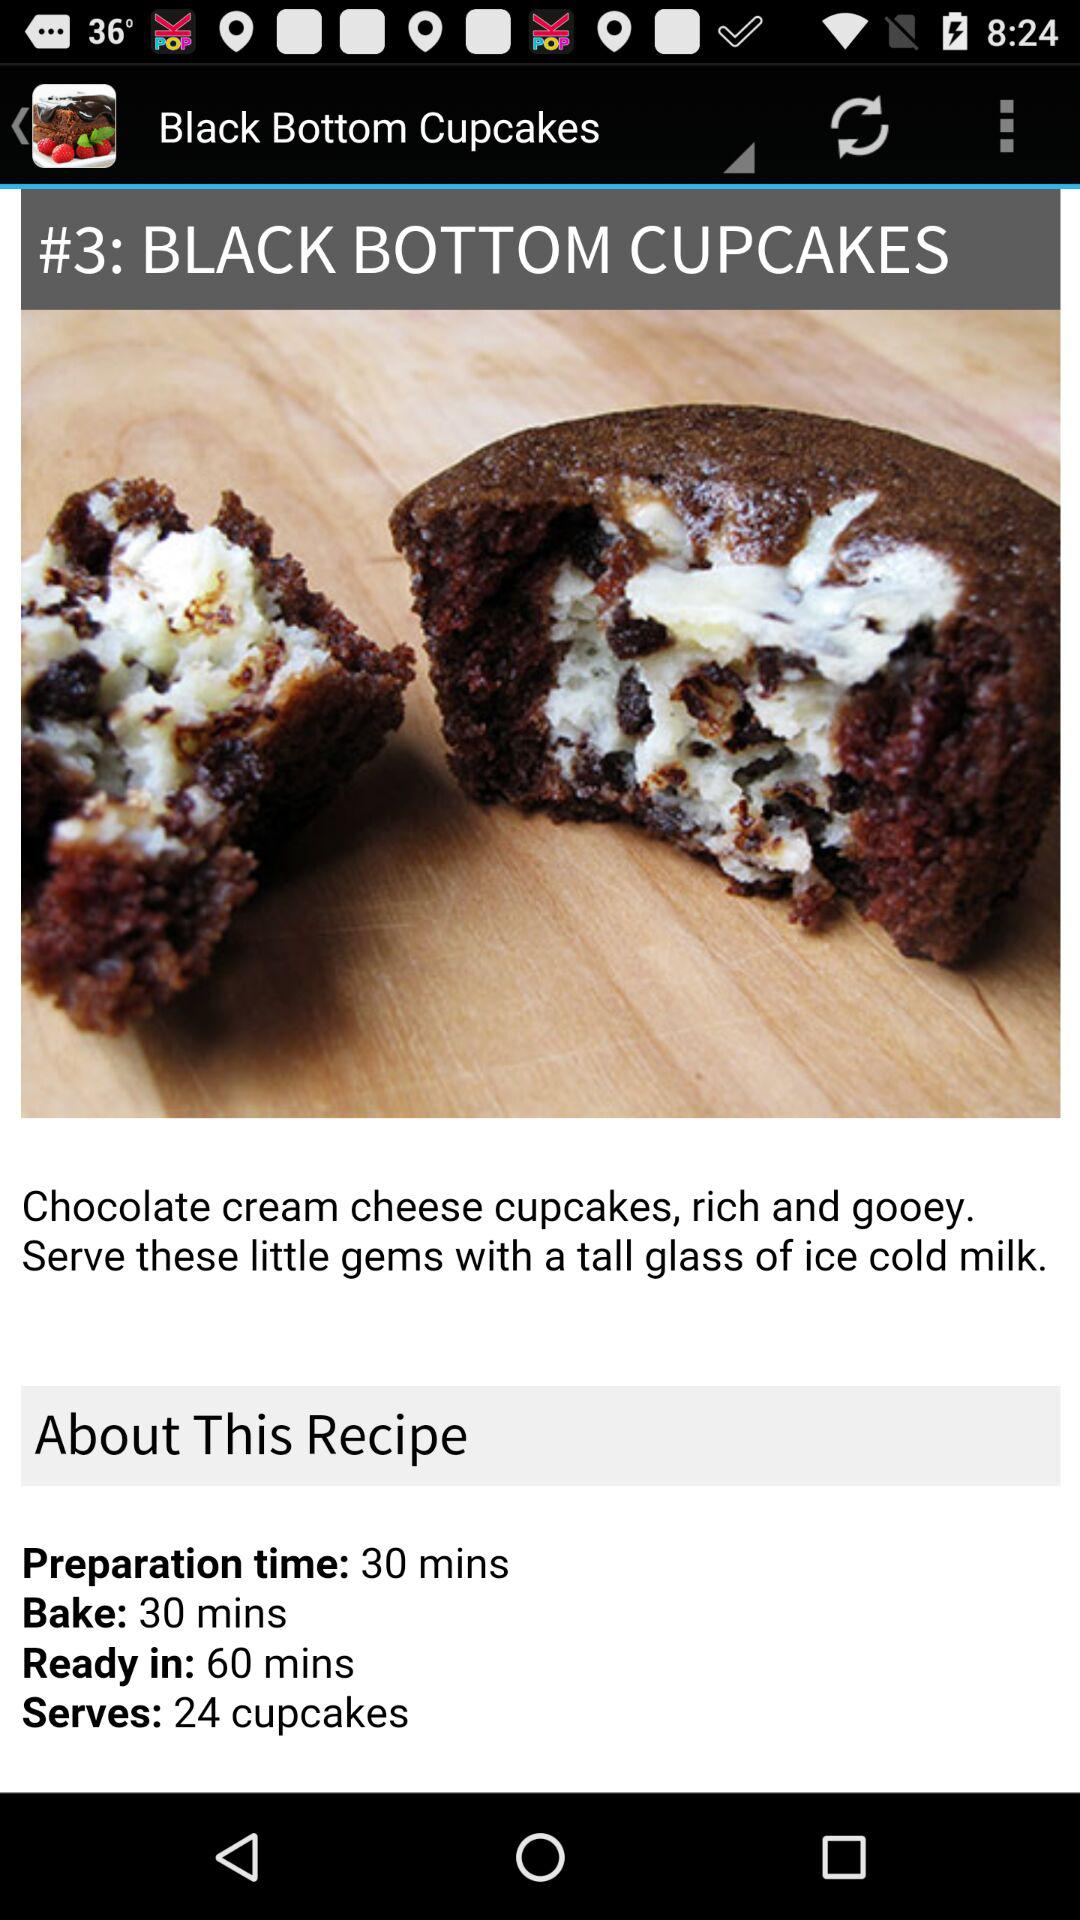What's the total count of cupcakes? The total count of cupcakes is 24. 